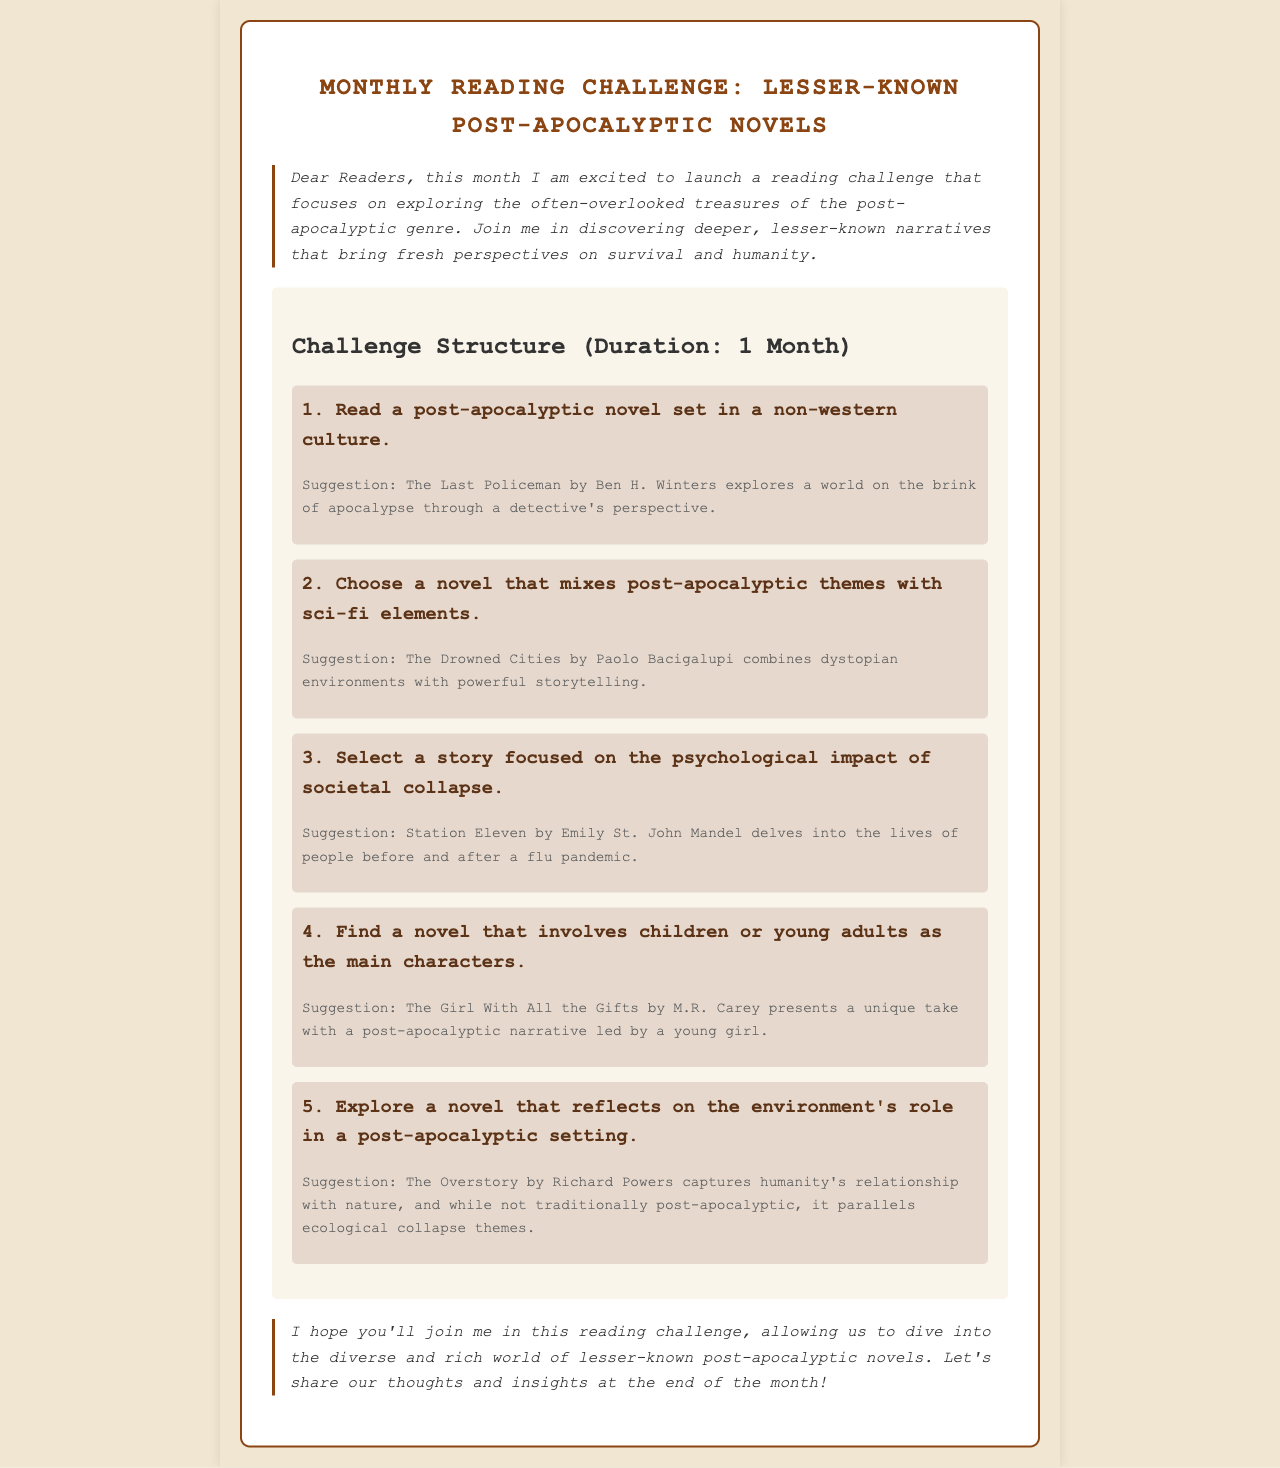What is the title of the reading challenge? The title of the reading challenge is mentioned at the beginning of the document.
Answer: Monthly Reading Challenge: Lesser-Known Post-Apocalyptic Novels How many prompts are included in the challenge? The number of prompts is directly presented in the challenge section of the document.
Answer: 5 Who is the suggested author for the first prompt? The author for the first prompt is listed in the suggestion associated with it.
Answer: Ben H. Winters What genre does the second prompt involve? The genre for the second prompt is specified within its description.
Answer: Sci-fi What is the main theme of the third prompt? The main theme is derived from the focus detailed in the prompt itself.
Answer: Psychological impact of societal collapse What role do children play in the fourth prompt? The role of children is described in the context of the novel selected for this prompt.
Answer: Main characters What type of ecological theme is suggested in the last prompt? The ecological theme is explained in the suggestion provided for the last prompt.
Answer: Environment's role in a post-apocalyptic setting What tone is established in the introduction? The introduction sets a specific mood that can be inferred from its language.
Answer: Excitement What is encouraged at the end of the month? The conclusion suggests an activity to participate in after the challenge.
Answer: Share thoughts and insights 